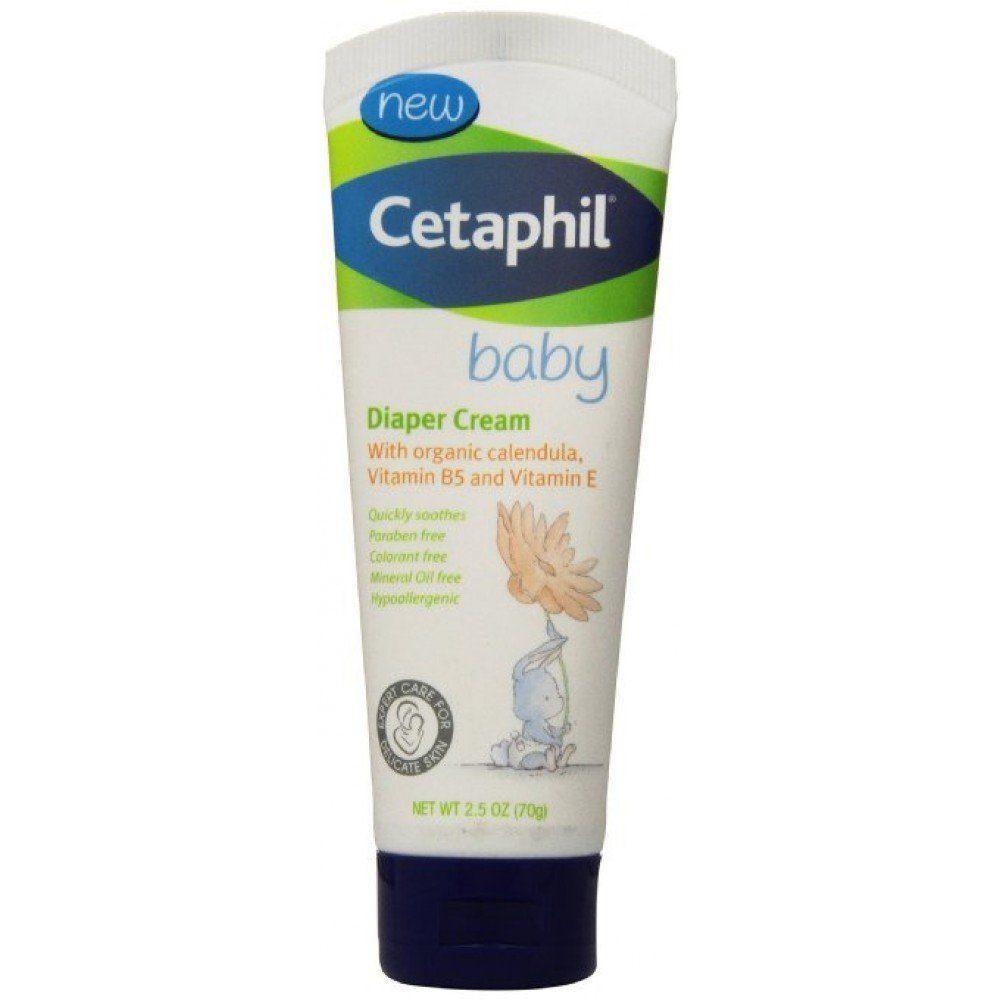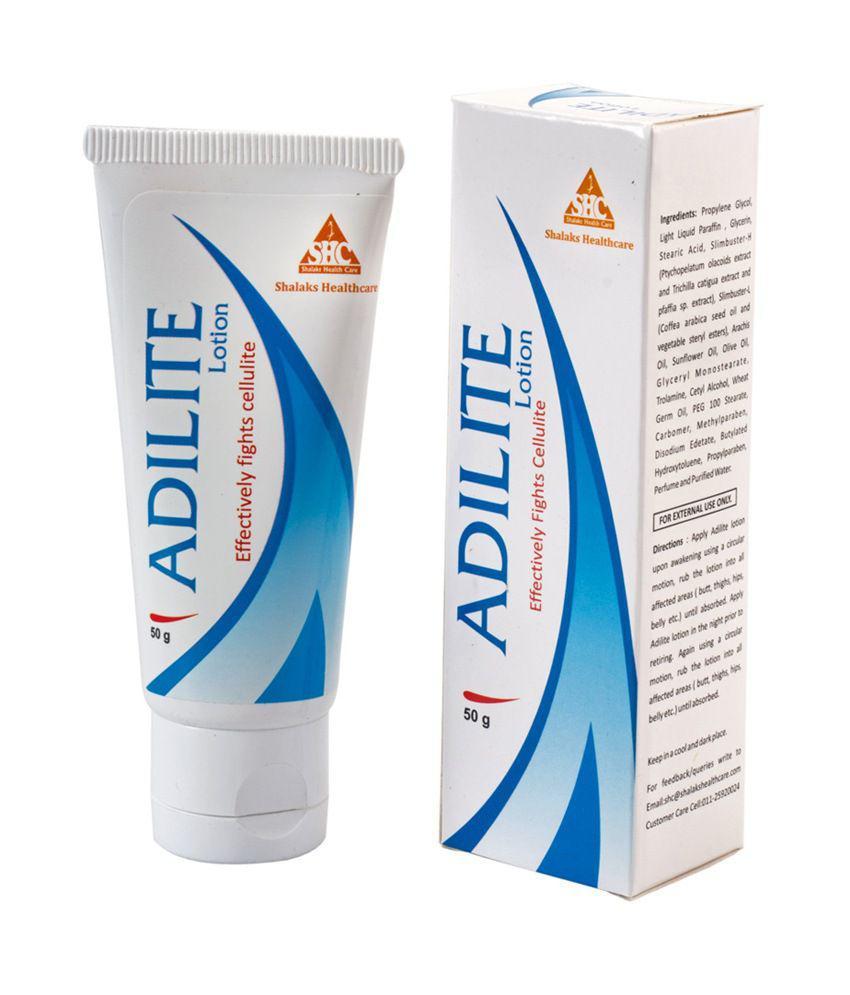The first image is the image on the left, the second image is the image on the right. For the images shown, is this caption "We see three packages of lotion." true? Answer yes or no. Yes. 